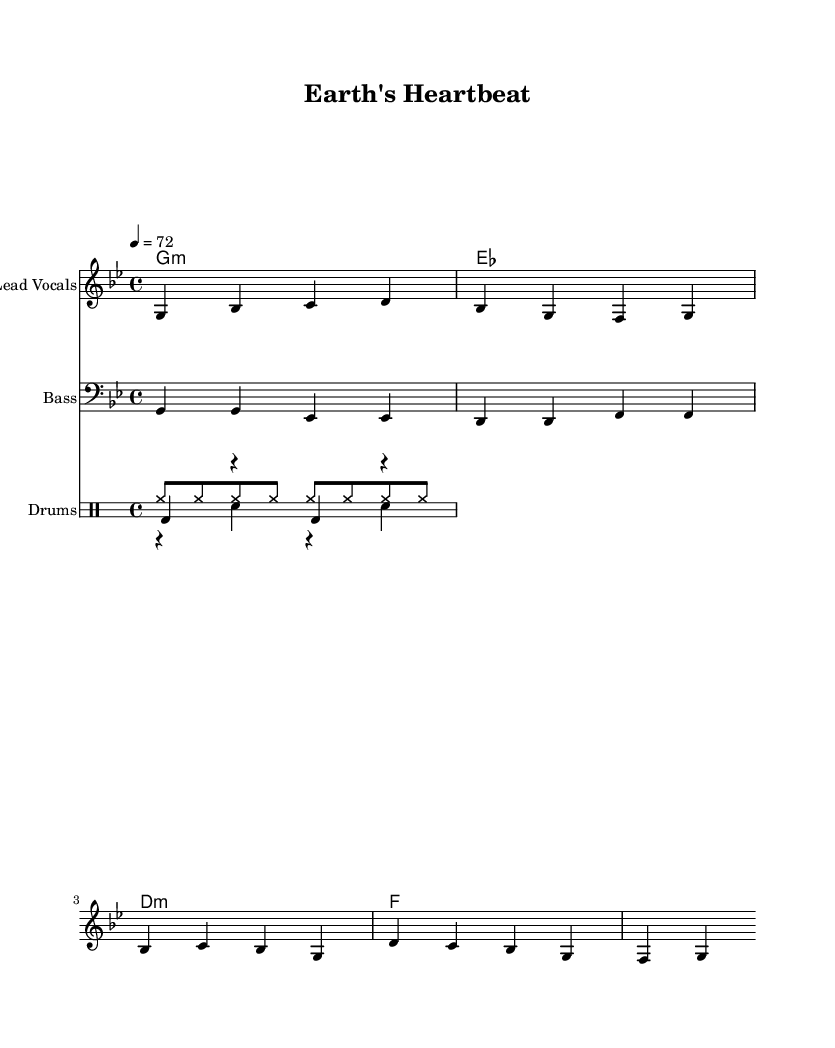What is the key signature of this music? The key signature is indicated at the beginning of the staff, showing one flat. This means the key is G minor, which has two flats (B flat and E flat) in its scale.
Answer: G minor What is the time signature of this music? The time signature is located after the key signature and indicates how many beats are in each measure. Here, it shows 4/4, meaning there are four beats in each measure.
Answer: 4/4 What is the tempo of this piece? The tempo is indicated in beats per minute, which is shown at the beginning of the score. Here, it states 4 equals 72, meaning the quarter note should be played at a rate of 72 beats per minute.
Answer: 72 Which instruments are featured in this piece? The instruments are indicated at the beginning of each staff. There are three staves shown: one for lead vocals, one for bass, and one for drums, which includes kick, snare, and hi-hat.
Answer: Lead Vocals, Bass, Drums What is the primary theme of the lyrics? The lyrics directly express a connection between humanity and nature, emphasizing harmony and unity, which reflects the spiritual theme often found in roots reggae music.
Answer: Spiritual connection between humans and nature How does the structure of this piece reflect typical reggae music? Reggae music often features offbeat rhythms and a laid-back feel. The bass and drum patterns in this piece support a steady, rhythmic groove alongside the vocal line, typical of roots reggae.
Answer: Offbeat rhythms, steady groove 